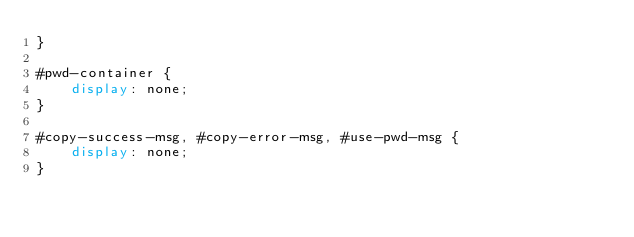<code> <loc_0><loc_0><loc_500><loc_500><_CSS_>}

#pwd-container {
    display: none;
}

#copy-success-msg, #copy-error-msg, #use-pwd-msg {
    display: none;
}
</code> 